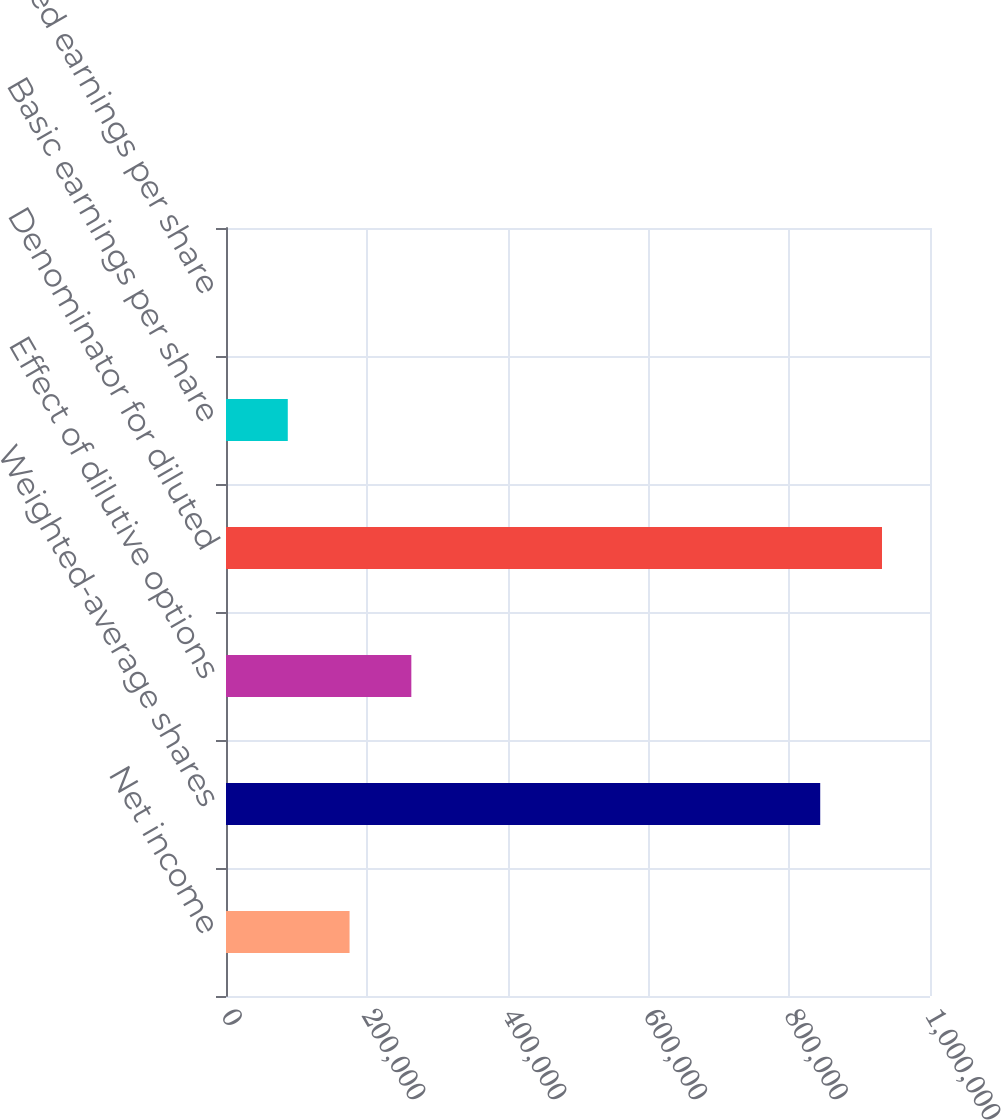Convert chart to OTSL. <chart><loc_0><loc_0><loc_500><loc_500><bar_chart><fcel>Net income<fcel>Weighted-average shares<fcel>Effect of dilutive options<fcel>Denominator for diluted<fcel>Basic earnings per share<fcel>Diluted earnings per share<nl><fcel>175507<fcel>844058<fcel>263259<fcel>931810<fcel>87754.6<fcel>2.27<nl></chart> 